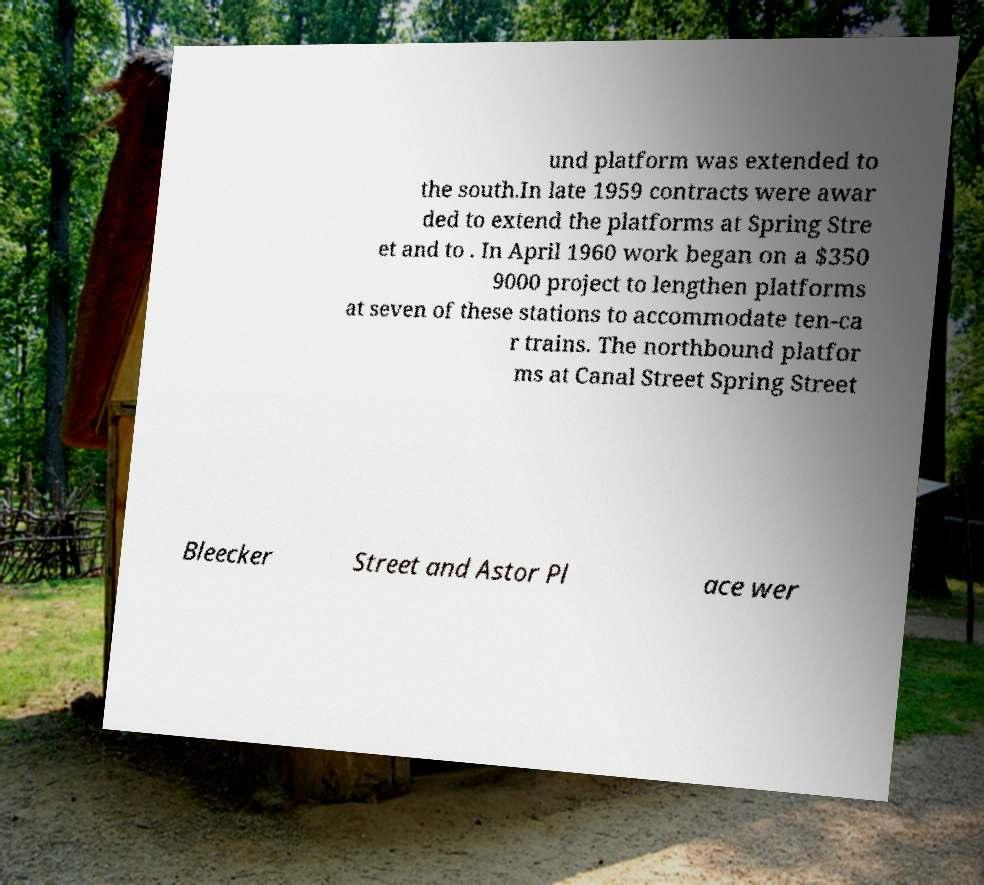I need the written content from this picture converted into text. Can you do that? und platform was extended to the south.In late 1959 contracts were awar ded to extend the platforms at Spring Stre et and to . In April 1960 work began on a $350 9000 project to lengthen platforms at seven of these stations to accommodate ten-ca r trains. The northbound platfor ms at Canal Street Spring Street Bleecker Street and Astor Pl ace wer 